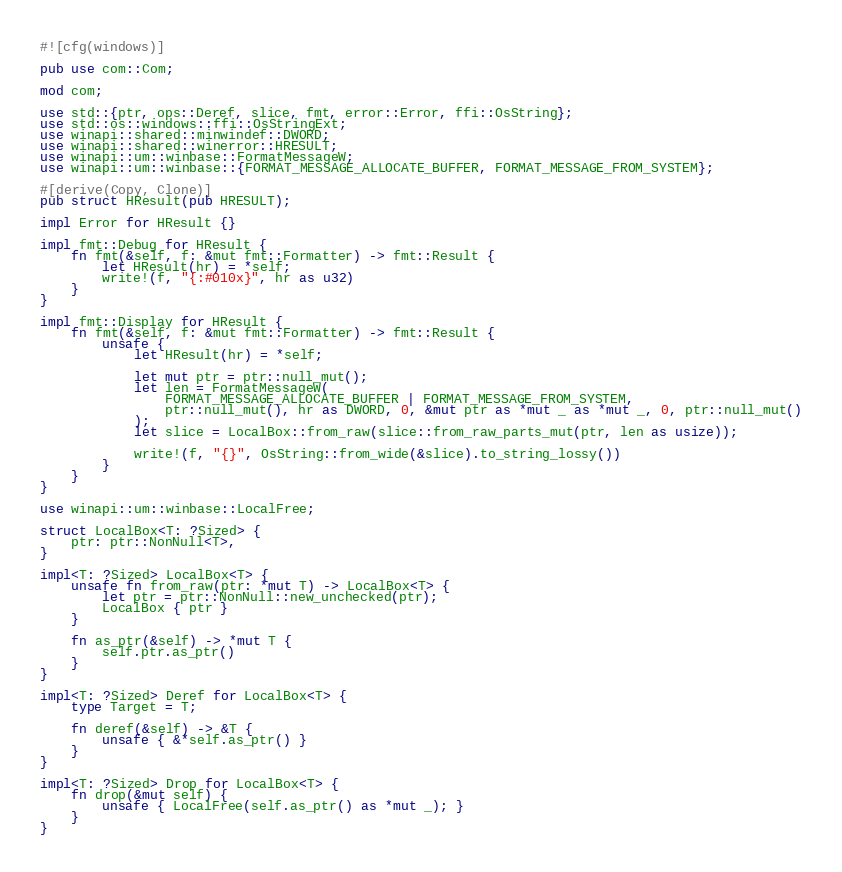<code> <loc_0><loc_0><loc_500><loc_500><_Rust_>#![cfg(windows)]

pub use com::Com;

mod com;

use std::{ptr, ops::Deref, slice, fmt, error::Error, ffi::OsString};
use std::os::windows::ffi::OsStringExt;
use winapi::shared::minwindef::DWORD;
use winapi::shared::winerror::HRESULT;
use winapi::um::winbase::FormatMessageW;
use winapi::um::winbase::{FORMAT_MESSAGE_ALLOCATE_BUFFER, FORMAT_MESSAGE_FROM_SYSTEM};

#[derive(Copy, Clone)]
pub struct HResult(pub HRESULT);

impl Error for HResult {}

impl fmt::Debug for HResult {
    fn fmt(&self, f: &mut fmt::Formatter) -> fmt::Result {
        let HResult(hr) = *self;
        write!(f, "{:#010x}", hr as u32)
    }
}

impl fmt::Display for HResult {
    fn fmt(&self, f: &mut fmt::Formatter) -> fmt::Result {
        unsafe {
            let HResult(hr) = *self;

            let mut ptr = ptr::null_mut();
            let len = FormatMessageW(
                FORMAT_MESSAGE_ALLOCATE_BUFFER | FORMAT_MESSAGE_FROM_SYSTEM,
                ptr::null_mut(), hr as DWORD, 0, &mut ptr as *mut _ as *mut _, 0, ptr::null_mut()
            );
            let slice = LocalBox::from_raw(slice::from_raw_parts_mut(ptr, len as usize));

            write!(f, "{}", OsString::from_wide(&slice).to_string_lossy())
        }
    }
}

use winapi::um::winbase::LocalFree;

struct LocalBox<T: ?Sized> {
    ptr: ptr::NonNull<T>,
}

impl<T: ?Sized> LocalBox<T> {
    unsafe fn from_raw(ptr: *mut T) -> LocalBox<T> {
        let ptr = ptr::NonNull::new_unchecked(ptr);
        LocalBox { ptr }
    }

    fn as_ptr(&self) -> *mut T {
        self.ptr.as_ptr()
    }
}

impl<T: ?Sized> Deref for LocalBox<T> {
    type Target = T;

    fn deref(&self) -> &T {
        unsafe { &*self.as_ptr() }
    }
}

impl<T: ?Sized> Drop for LocalBox<T> {
    fn drop(&mut self) {
        unsafe { LocalFree(self.as_ptr() as *mut _); }
    }
}
</code> 